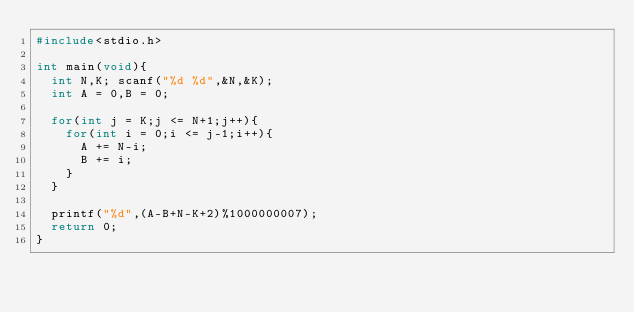<code> <loc_0><loc_0><loc_500><loc_500><_C_>#include<stdio.h>

int main(void){
  int N,K; scanf("%d %d",&N,&K);
  int A = 0,B = 0;

  for(int j = K;j <= N+1;j++){
    for(int i = 0;i <= j-1;i++){
      A += N-i;
      B += i;
    }
  }

  printf("%d",(A-B+N-K+2)%1000000007);
  return 0;
}
</code> 